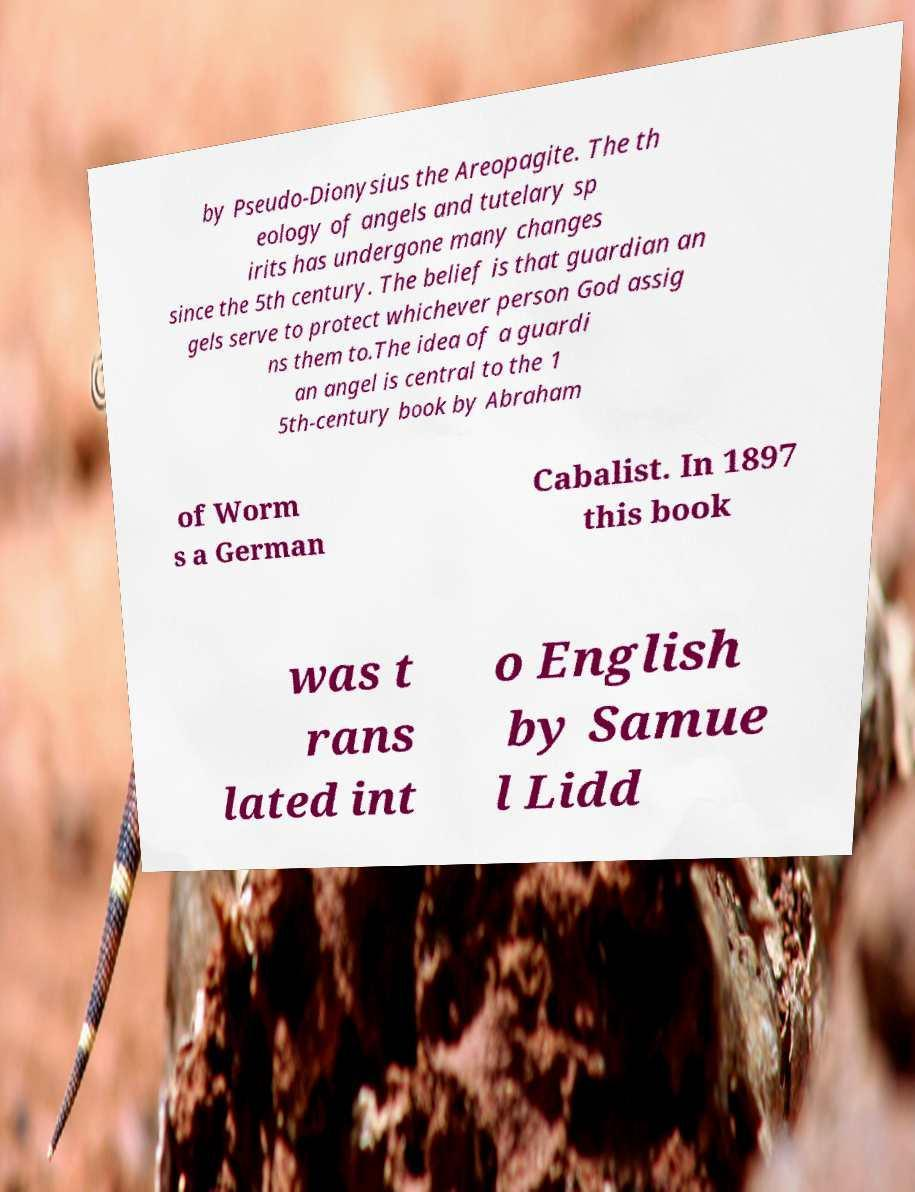Please identify and transcribe the text found in this image. by Pseudo-Dionysius the Areopagite. The th eology of angels and tutelary sp irits has undergone many changes since the 5th century. The belief is that guardian an gels serve to protect whichever person God assig ns them to.The idea of a guardi an angel is central to the 1 5th-century book by Abraham of Worm s a German Cabalist. In 1897 this book was t rans lated int o English by Samue l Lidd 